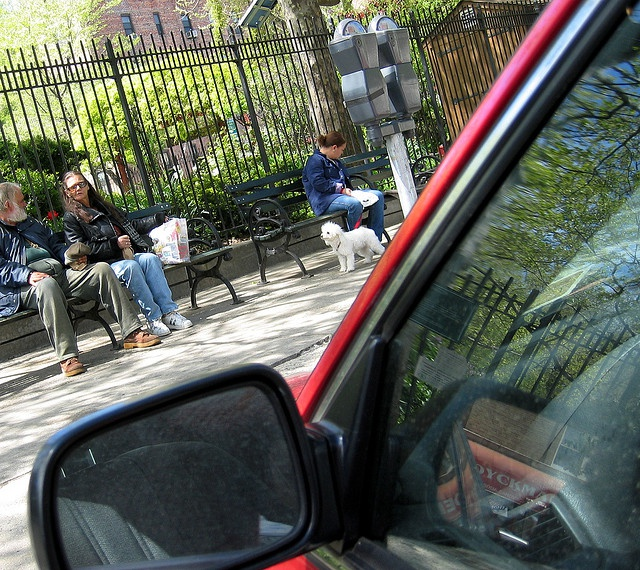Describe the objects in this image and their specific colors. I can see car in white, black, gray, purple, and darkgreen tones, people in white, black, gray, darkgray, and lightgray tones, people in white, black, and gray tones, bench in white, black, gray, darkblue, and purple tones, and bench in white, black, gray, and darkgray tones in this image. 